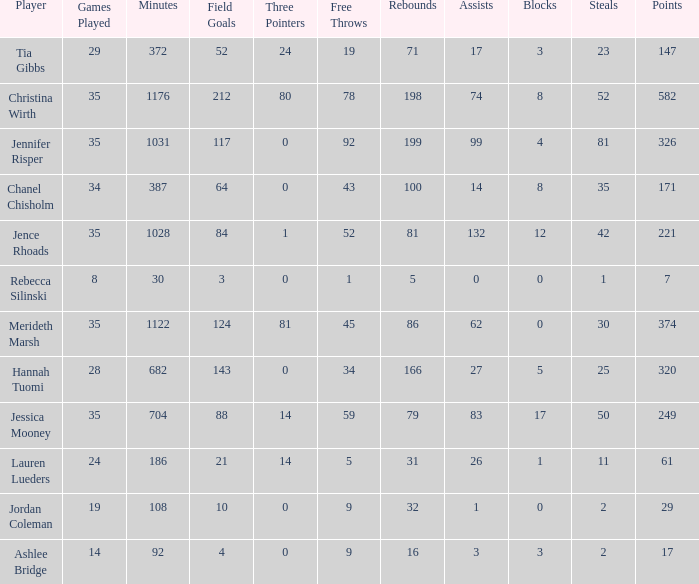How many blockings occured in the game with 198 rebounds? 8.0. 